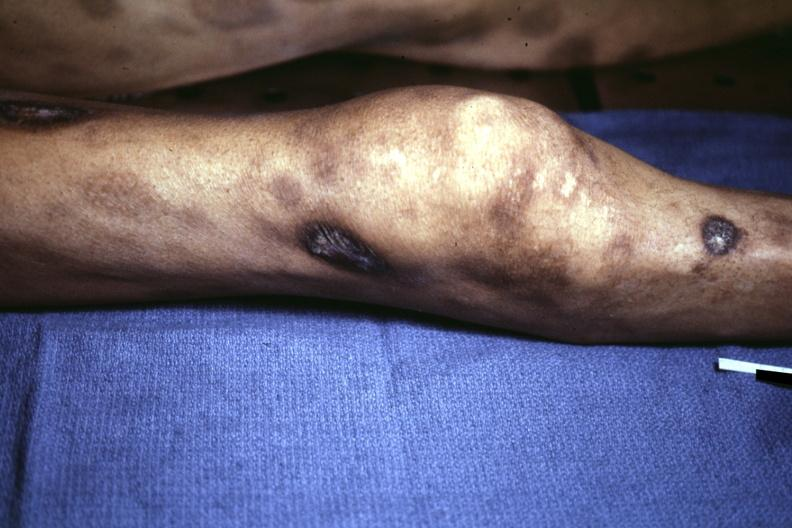what does this image show?
Answer the question using a single word or phrase. View of knee at autopsy ecchymoses with necrotic and ulcerated centers looks like pyoderma gangrenosum 